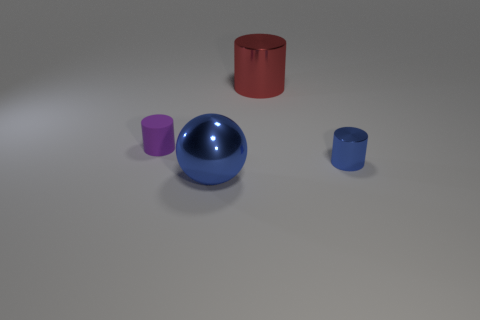Add 2 blue things. How many objects exist? 6 Subtract all cylinders. How many objects are left? 1 Subtract 0 purple blocks. How many objects are left? 4 Subtract all large red cylinders. Subtract all cylinders. How many objects are left? 0 Add 3 tiny blue cylinders. How many tiny blue cylinders are left? 4 Add 3 big metal cylinders. How many big metal cylinders exist? 4 